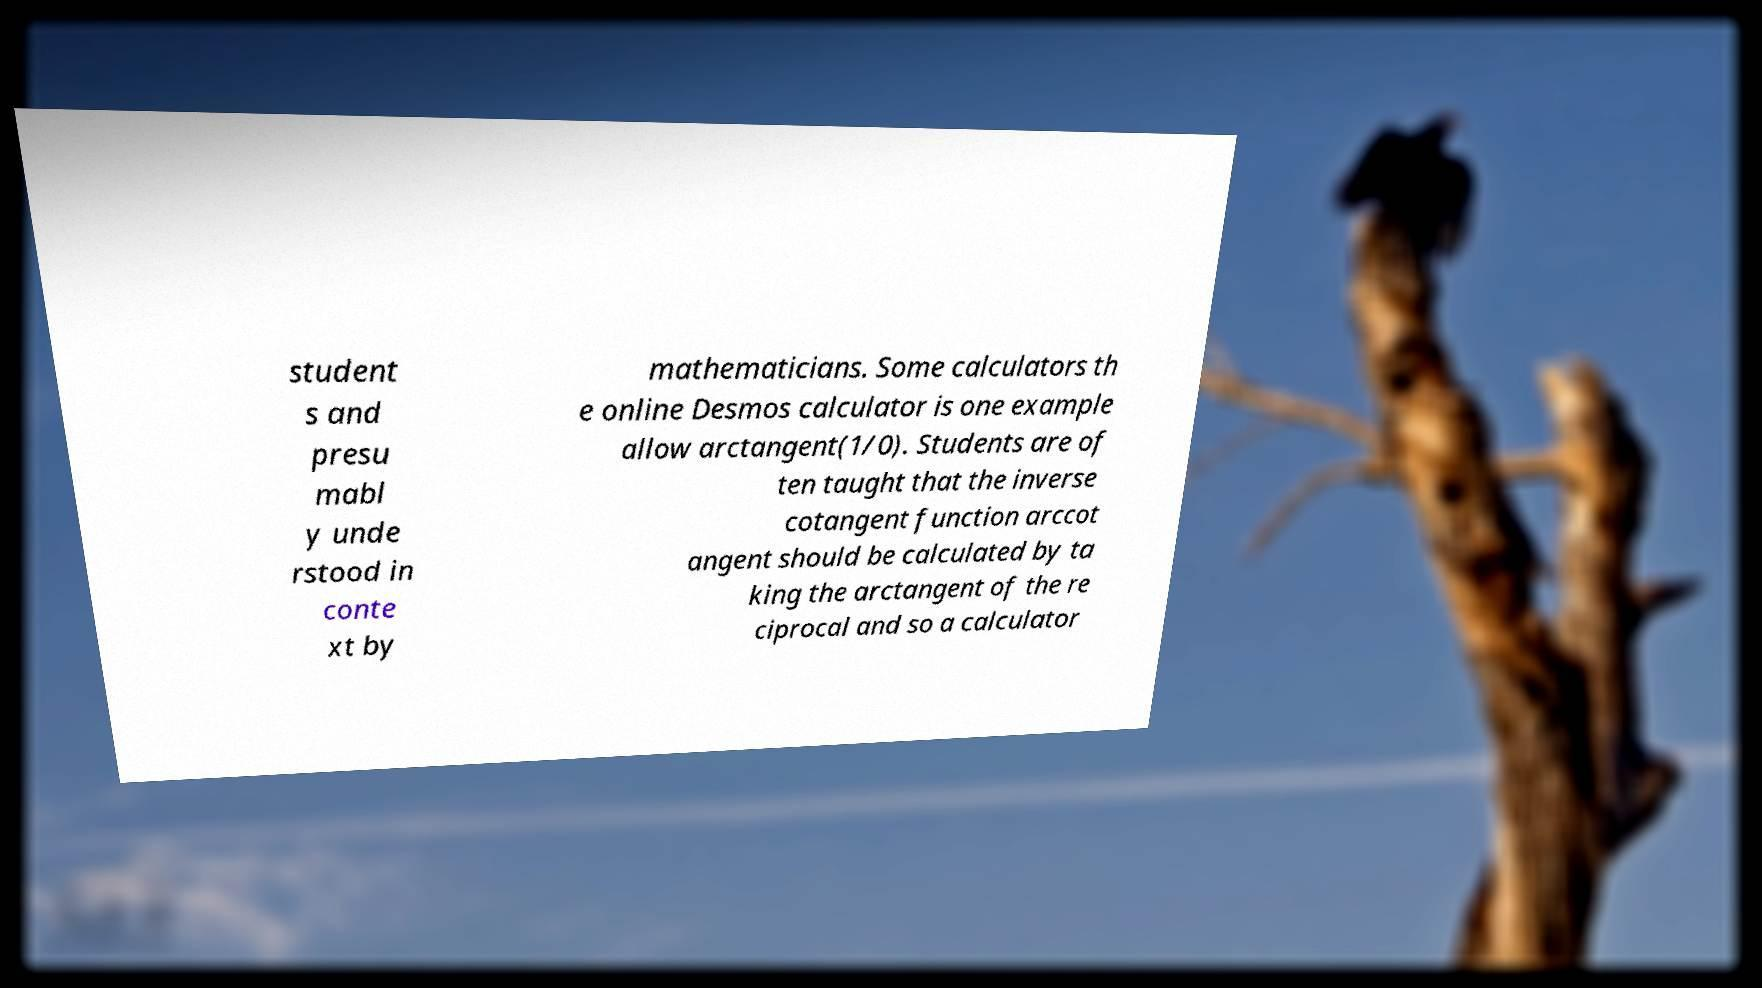There's text embedded in this image that I need extracted. Can you transcribe it verbatim? student s and presu mabl y unde rstood in conte xt by mathematicians. Some calculators th e online Desmos calculator is one example allow arctangent(1/0). Students are of ten taught that the inverse cotangent function arccot angent should be calculated by ta king the arctangent of the re ciprocal and so a calculator 